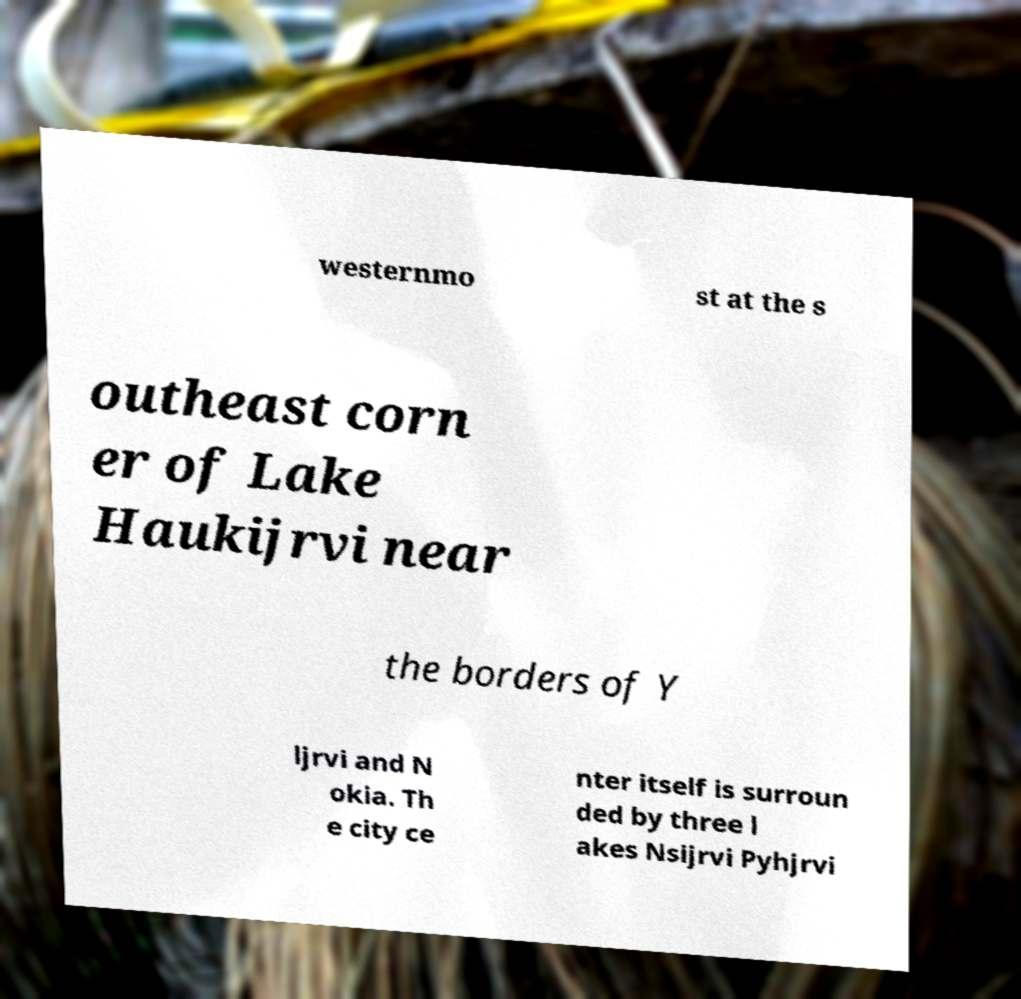Can you accurately transcribe the text from the provided image for me? westernmo st at the s outheast corn er of Lake Haukijrvi near the borders of Y ljrvi and N okia. Th e city ce nter itself is surroun ded by three l akes Nsijrvi Pyhjrvi 